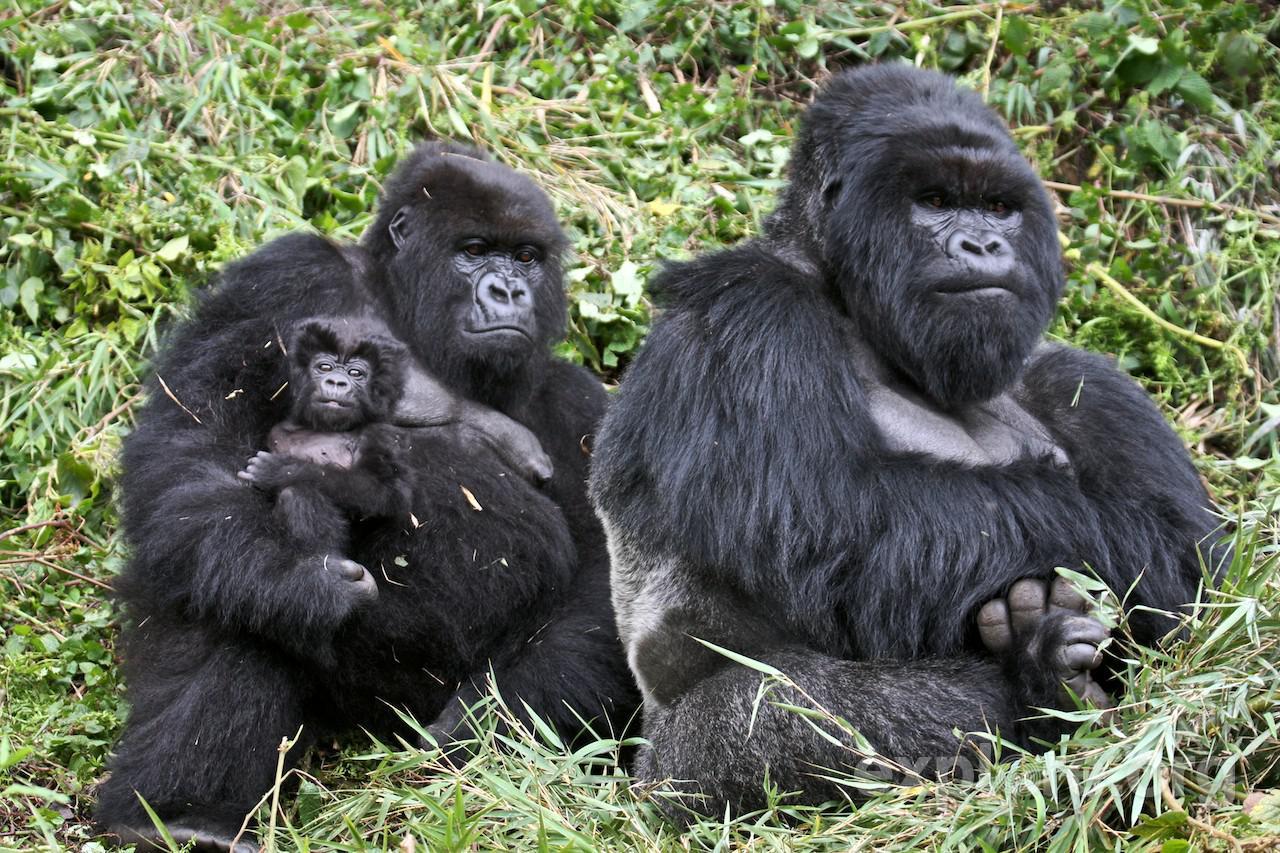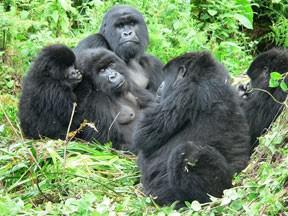The first image is the image on the left, the second image is the image on the right. For the images shown, is this caption "The left image contains exactly four gorillas." true? Answer yes or no. No. The first image is the image on the left, the second image is the image on the right. Assess this claim about the two images: "In each image, the gorilla closest to the camera is on all fours.". Correct or not? Answer yes or no. No. 